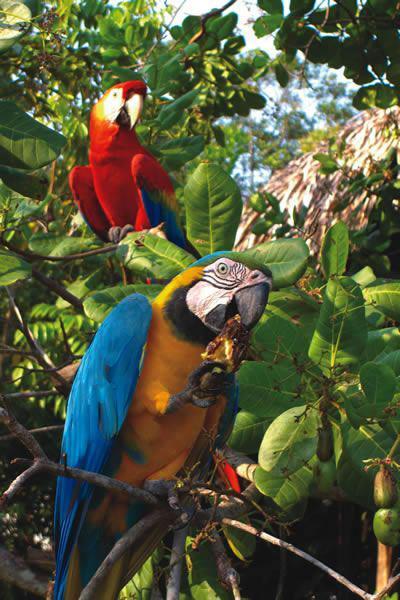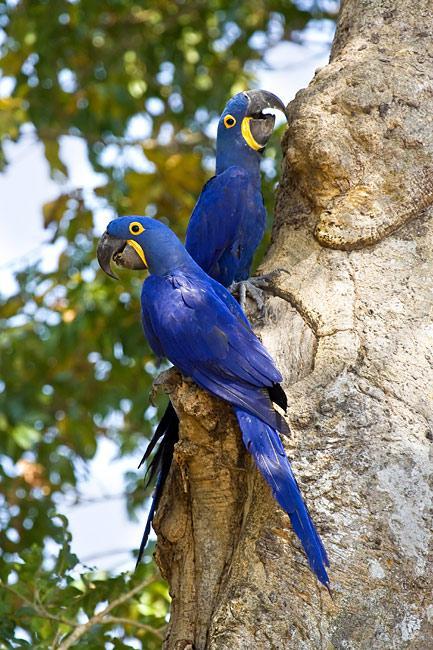The first image is the image on the left, the second image is the image on the right. Considering the images on both sides, is "One image includes a red-headed bird and a bird with blue-and-yellow coloring." valid? Answer yes or no. Yes. 